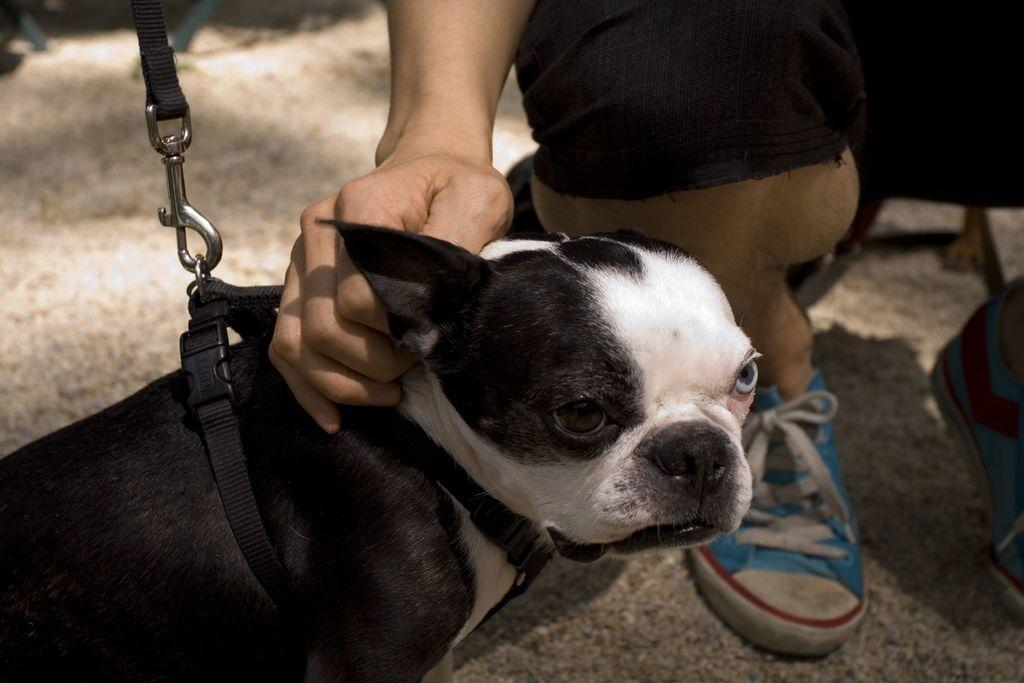What type of animal is in the picture? There is a dog in the picture. What is the dog wearing? The dog is wearing a belt and hook. What colors can be seen on the dog? The dog is black and white in color. Who is near the dog in the picture? There is a person sitting near the dog. What is the person doing with the dog? The person is touching the dog. What type of haircut does the goldfish have in the image? There is no goldfish present in the image, so it is not possible to determine the type of haircut it might have. 